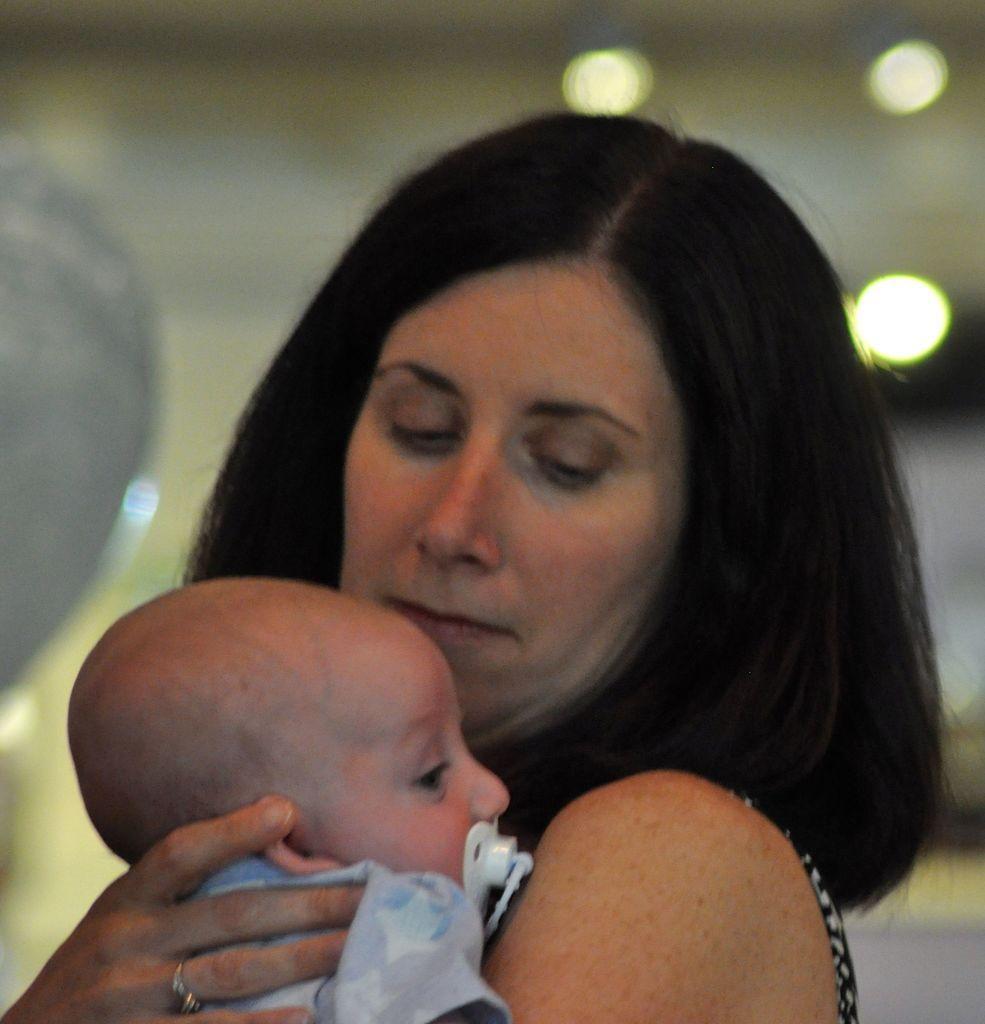Could you give a brief overview of what you see in this image? In the center of the image we can see a lady holding a baby. In the background there are lights. 